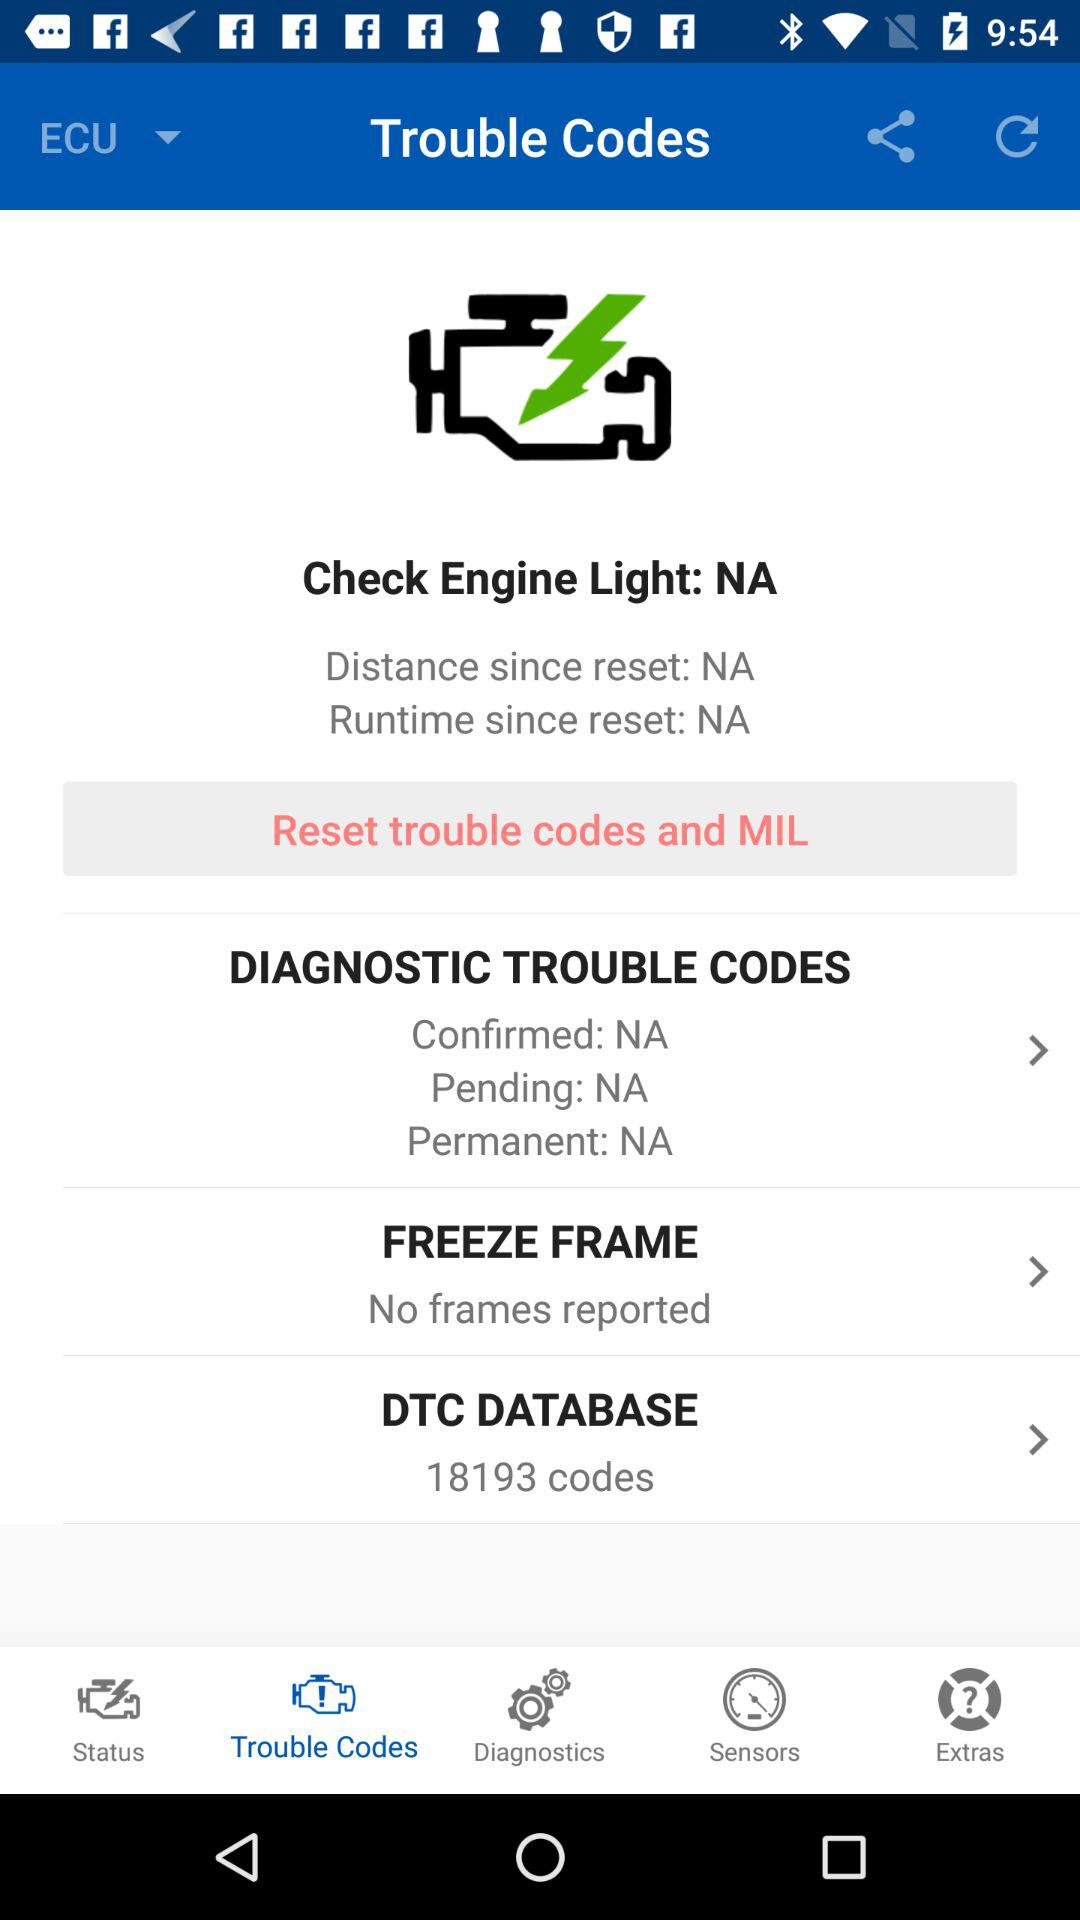What is the total number of codes in the DTC database? The total number of codes is 18193. 